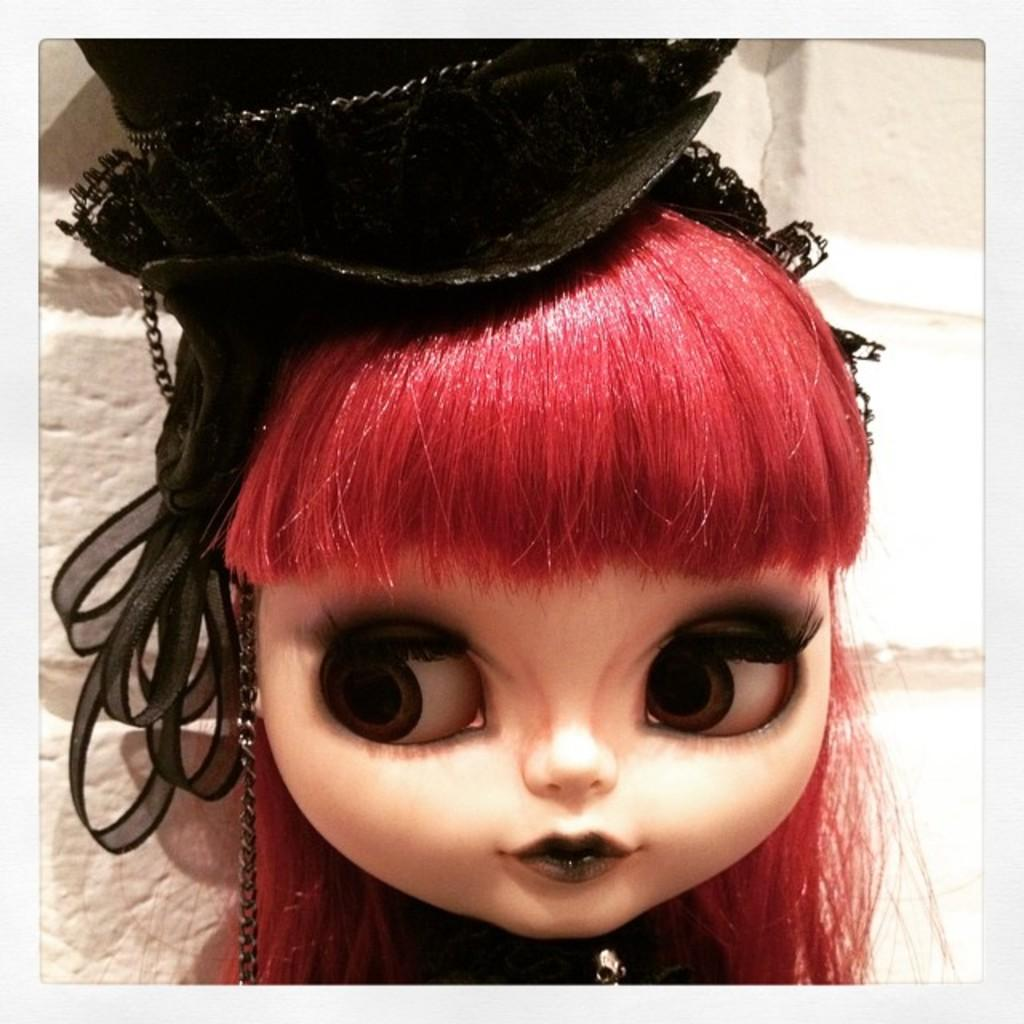What is the main subject in the image? There is a doll in the image. Can you describe the background of the image? There is a wall visible on the backside of the image. How high does the grandfather jump in the image? There is no grandfather present in the image, so it is not possible to answer that question. 